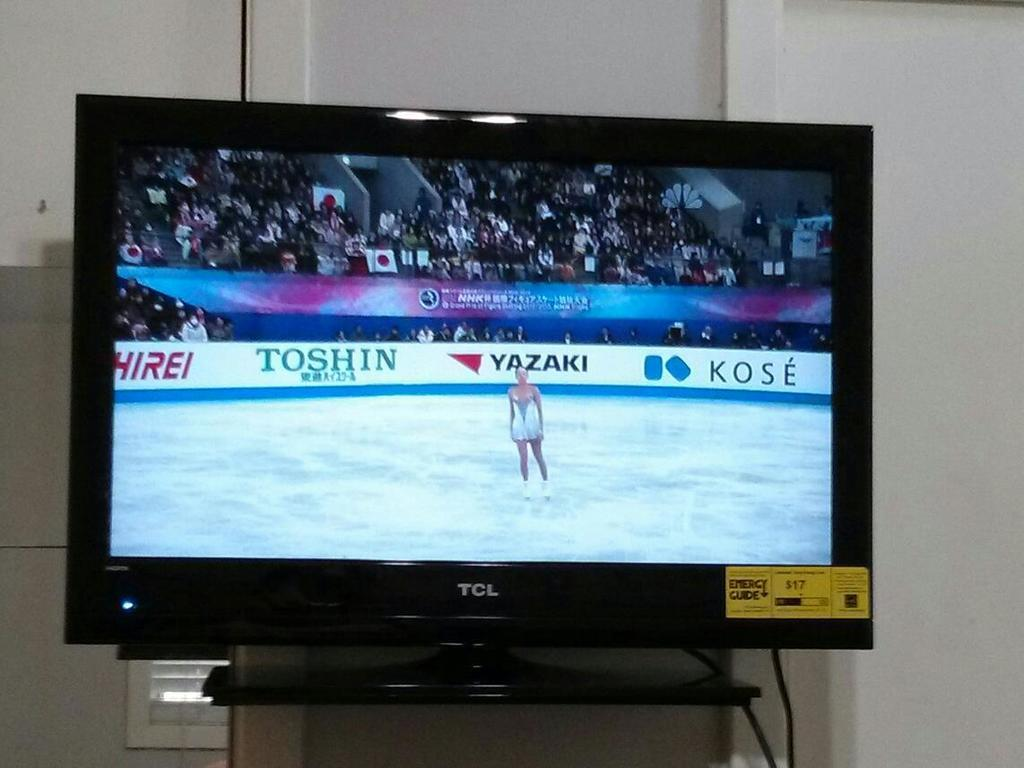<image>
Relay a brief, clear account of the picture shown. A women is ice skating on a TCL television screen. 